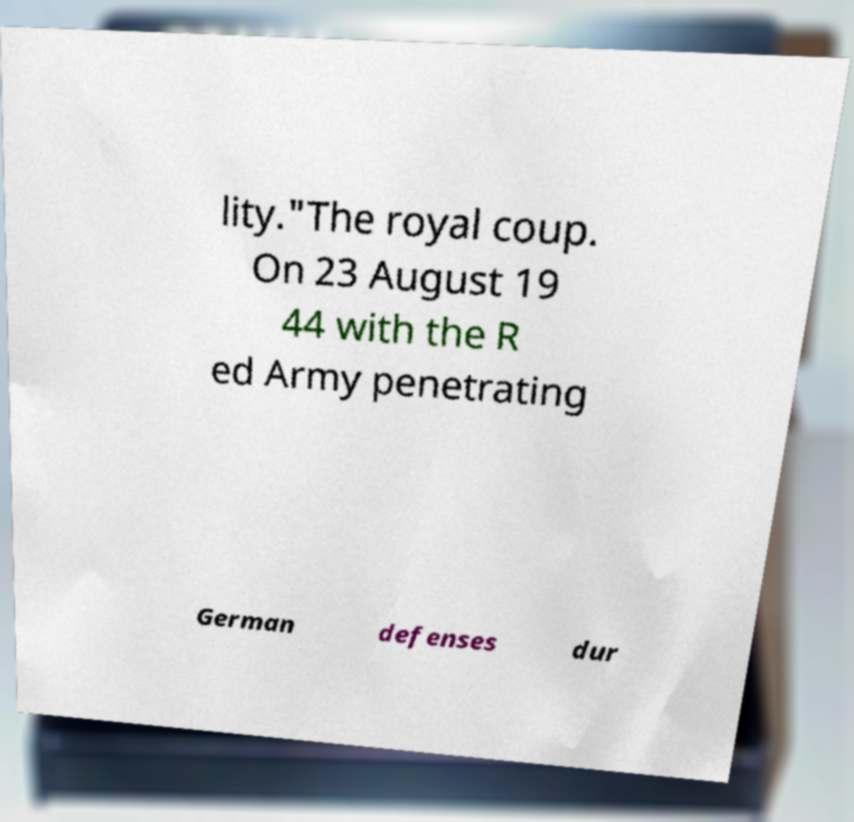For documentation purposes, I need the text within this image transcribed. Could you provide that? lity."The royal coup. On 23 August 19 44 with the R ed Army penetrating German defenses dur 